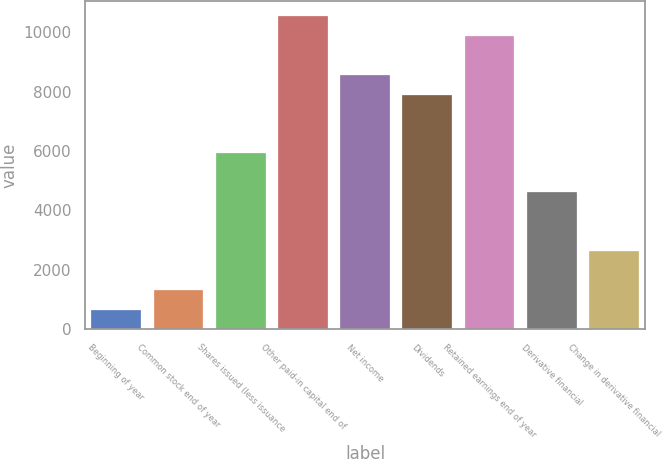Convert chart to OTSL. <chart><loc_0><loc_0><loc_500><loc_500><bar_chart><fcel>Beginning of year<fcel>Common stock end of year<fcel>Shares issued (less issuance<fcel>Other paid-in capital end of<fcel>Net income<fcel>Dividends<fcel>Retained earnings end of year<fcel>Derivative financial<fcel>Change in derivative financial<nl><fcel>660.01<fcel>1318.12<fcel>5924.89<fcel>10531.7<fcel>8557.33<fcel>7899.22<fcel>9873.55<fcel>4608.67<fcel>2634.34<nl></chart> 